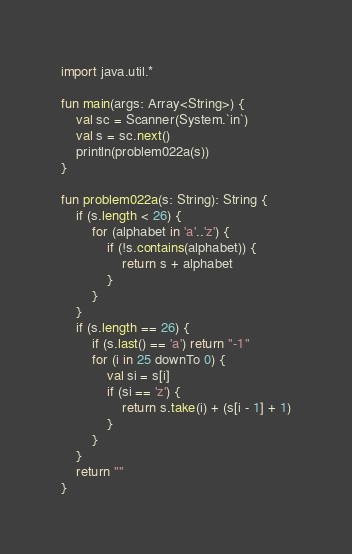Convert code to text. <code><loc_0><loc_0><loc_500><loc_500><_Kotlin_>import java.util.*

fun main(args: Array<String>) {
    val sc = Scanner(System.`in`)
    val s = sc.next()
    println(problem022a(s))
}

fun problem022a(s: String): String {
    if (s.length < 26) {
        for (alphabet in 'a'..'z') {
            if (!s.contains(alphabet)) {
                return s + alphabet
            }
        }
    }
    if (s.length == 26) {
        if (s.last() == 'a') return "-1"
        for (i in 25 downTo 0) {
            val si = s[i]
            if (si == 'z') {
                return s.take(i) + (s[i - 1] + 1)
            }
        }
    }
    return ""
}</code> 